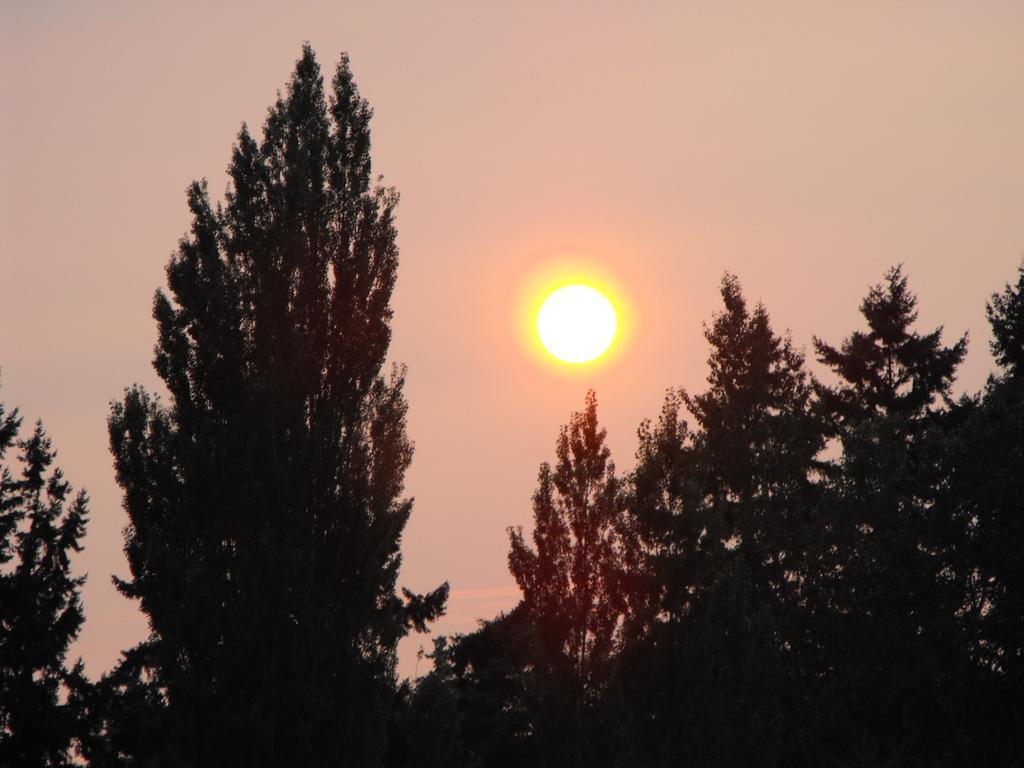Please provide a concise description of this image. There are trees. In the background we can see the sun and sky. 